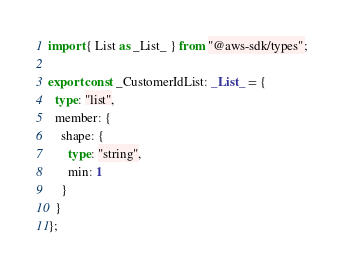<code> <loc_0><loc_0><loc_500><loc_500><_TypeScript_>import { List as _List_ } from "@aws-sdk/types";

export const _CustomerIdList: _List_ = {
  type: "list",
  member: {
    shape: {
      type: "string",
      min: 1
    }
  }
};
</code> 